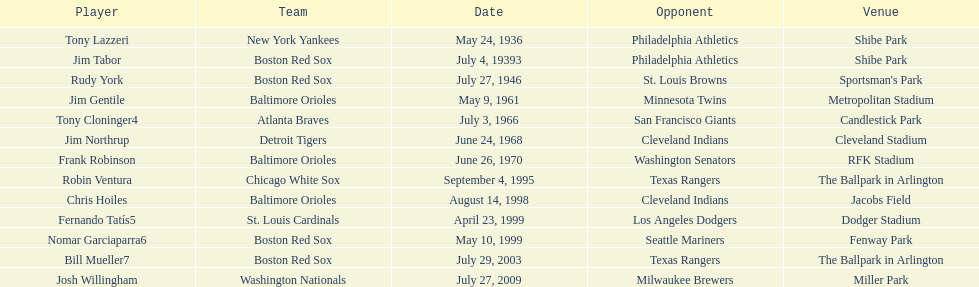In 1936, which player was on the new york yankees team? Tony Lazzeri. 